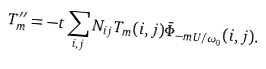Convert formula to latex. <formula><loc_0><loc_0><loc_500><loc_500>T ^ { \prime \prime } _ { m } = - t \sum _ { i , j } N _ { i j } T _ { m } ( i , j ) \bar { \Phi } _ { - m U / \omega _ { 0 } } ( i , j ) .</formula> 